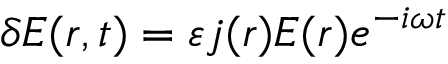Convert formula to latex. <formula><loc_0><loc_0><loc_500><loc_500>\delta E ( r , t ) = \varepsilon j ( r ) E ( r ) e ^ { - i \omega t }</formula> 